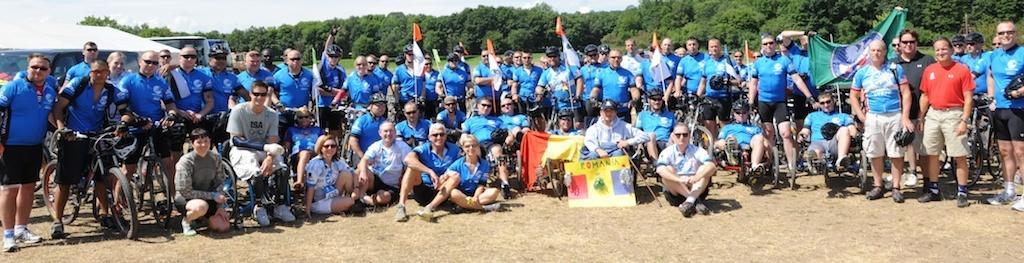Can you describe this image briefly? In this image there are people standing and some of them are sitting. We can see wheelchairs and bicycles. There are flags. In the center there is a board. In the background there are vehicles, trees and sky. 